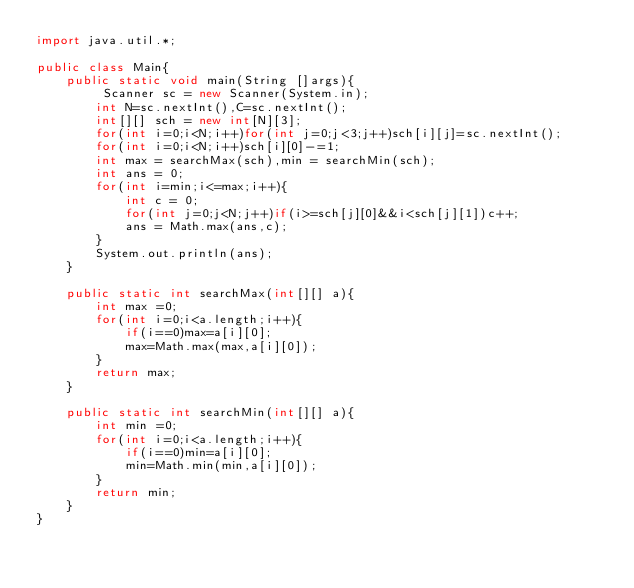<code> <loc_0><loc_0><loc_500><loc_500><_Java_>import java.util.*;

public class Main{
    public static void main(String []args){
         Scanner sc = new Scanner(System.in);
        int N=sc.nextInt(),C=sc.nextInt();
        int[][] sch = new int[N][3];
        for(int i=0;i<N;i++)for(int j=0;j<3;j++)sch[i][j]=sc.nextInt();
        for(int i=0;i<N;i++)sch[i][0]-=1;
        int max = searchMax(sch),min = searchMin(sch);
        int ans = 0;
        for(int i=min;i<=max;i++){
            int c = 0;
            for(int j=0;j<N;j++)if(i>=sch[j][0]&&i<sch[j][1])c++;
            ans = Math.max(ans,c);
        }
        System.out.println(ans);
    }
    
    public static int searchMax(int[][] a){
        int max =0;
        for(int i=0;i<a.length;i++){
            if(i==0)max=a[i][0];
            max=Math.max(max,a[i][0]);
        }
        return max;
    }
    
    public static int searchMin(int[][] a){
        int min =0;
        for(int i=0;i<a.length;i++){
            if(i==0)min=a[i][0];
            min=Math.min(min,a[i][0]);
        }
        return min;
    }
}</code> 